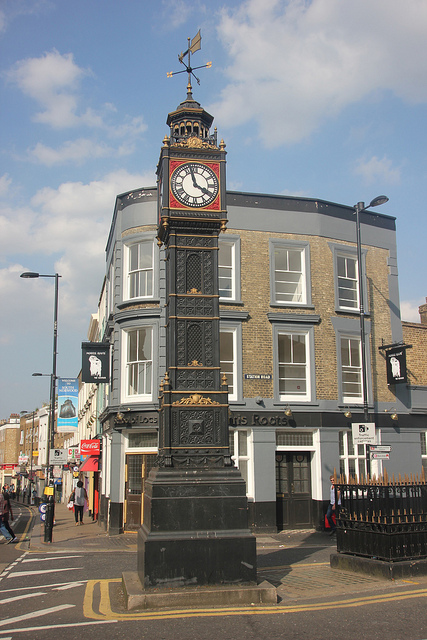Describe a realistic scenario that could happen in this location on a weekday morning. On a weekday morning, the street might be busy with people commuting to work. You'd see business professionals walking briskly, coffee in hand, heading towards their offices. The shops might be opening up, with employees preparing their storefronts for the day's customers. Delivery trucks could be seen unloading goods in front of stores, and the street would have a mix of sounds from chatter, footsteps, and vehicles passing by. Describe a short, realistic scenario that could happen here during the evening. In the evening, the street might be filled with people heading to dinner at nearby restaurants or meeting friends for a night out. The clock tower could be beautifully lit, standing as a glowing beacon that adds to the city's nighttime charm. Street musicians might be playing, adding a pleasant background melody to the bustling evening ambience. 